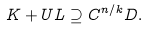<formula> <loc_0><loc_0><loc_500><loc_500>K + U L \supseteq C ^ { n / k } D .</formula> 